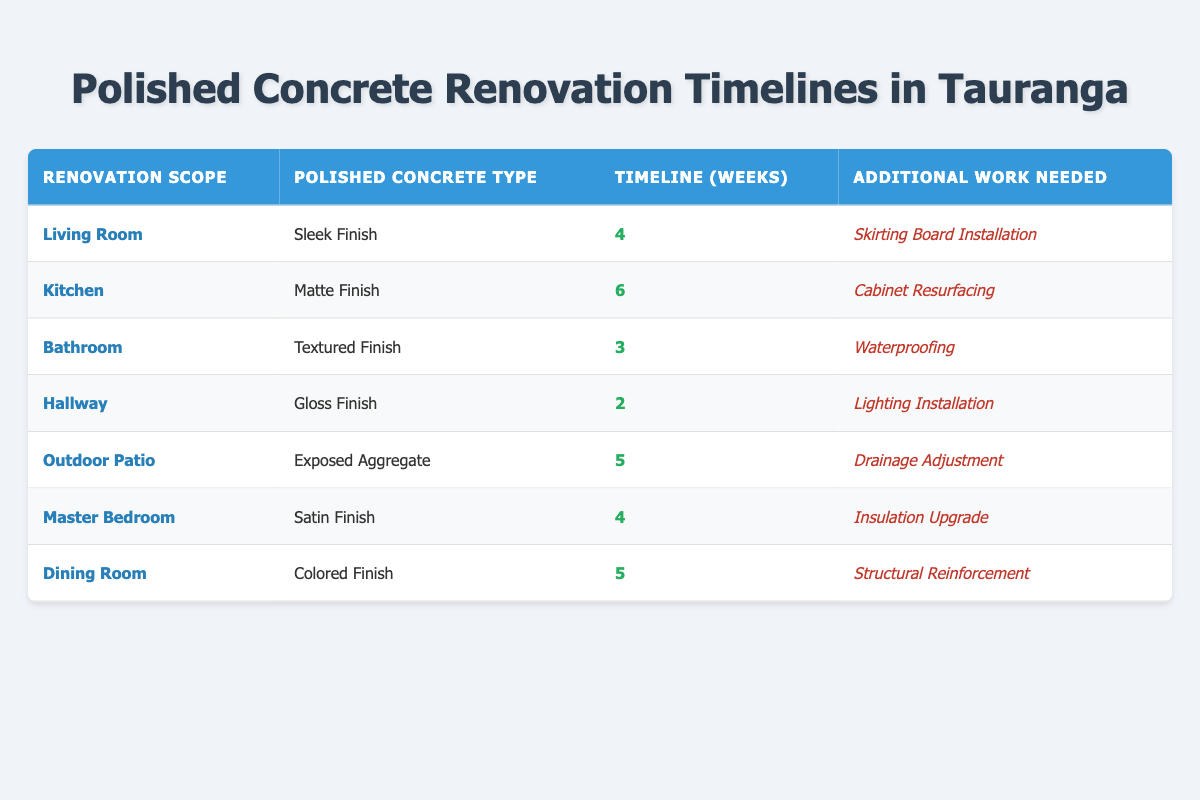What is the timeline for renovating the Kitchen with a Matte Finish? The table shows that the Kitchen has a timeline of 6 weeks for the renovation with a Matte Finish type of polished concrete.
Answer: 6 weeks Which renovation scope has the shortest timeline? By examining the timelines, the Hallway is listed with a timeline of only 2 weeks, which is the shortest among all the renovation scopes.
Answer: Hallway How many weeks will it take to renovate both the Living Room and Master Bedroom? The Living Room takes 4 weeks and the Master Bedroom also takes 4 weeks. By adding these values (4 + 4), the total timeline for both is 8 weeks.
Answer: 8 weeks Is waterproofing necessary for the Bathroom renovation? Yes, the table indicates that waterproofing is listed as the additional work needed for the Bathroom renovation, confirming that it is necessary.
Answer: Yes What is the average timeline for all renovation scopes listed? To find the average, first sum up all the timelines: (4 + 6 + 3 + 2 + 5 + 4 + 5) = 29 weeks. There are 7 renovation scopes, so the average is 29 / 7, which equals approximately 4.14 weeks.
Answer: Approximately 4.14 weeks For which polished concrete type is the additional work of Drainage Adjustment required? The table shows that Drainage Adjustment is required for the Outdoor Patio, which has an Exposed Aggregate polished concrete type.
Answer: Exposed Aggregate Among the renovation scopes, which one requires structural reinforcement, and how long will it take? The Dining Room is the only scope that requires structural reinforcement, and it has a timeline of 5 weeks for the renovation.
Answer: Dining Room, 5 weeks What is the total timeline for renovations that require an installation or upgrade as additional work? The renovations that require installation or upgrade are Living Room (Skirting Board Installation, 4 weeks), Hallway (Lighting Installation, 2 weeks), Master Bedroom (Insulation Upgrade, 4 weeks). The total timeline for these is 4 + 2 + 4 = 10 weeks.
Answer: 10 weeks Is there any renovation scope with a timeline shorter than 3 weeks? Yes, the Hallway renovation has a timeline of 2 weeks, which is shorter than 3 weeks, indicating that it is indeed the only scope below this threshold.
Answer: Yes 